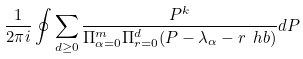Convert formula to latex. <formula><loc_0><loc_0><loc_500><loc_500>\frac { 1 } { 2 \pi i } \oint \sum _ { d \geq 0 } \frac { P ^ { k } } { \Pi _ { \alpha = 0 } ^ { m } \Pi _ { r = 0 } ^ { d } ( P - \lambda _ { \alpha } - r \ h b ) } d P</formula> 